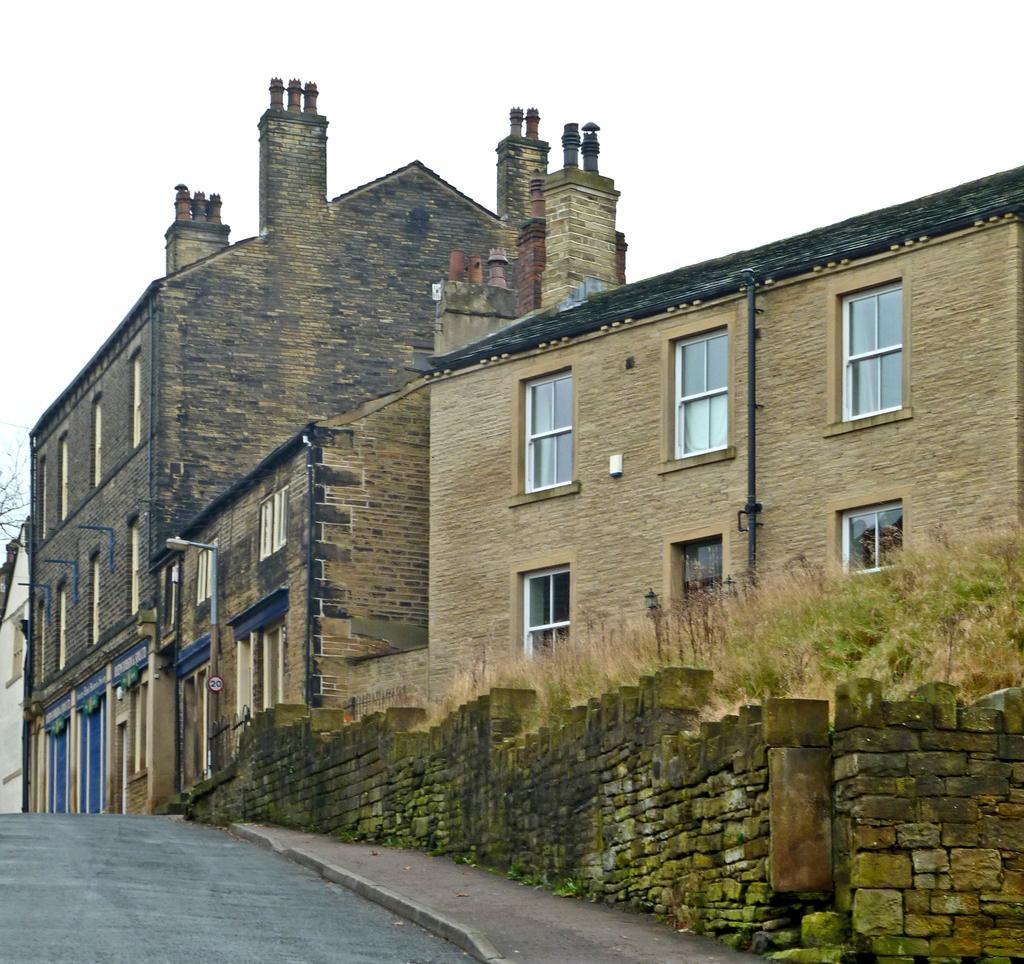In one or two sentences, can you explain what this image depicts? In this image there is road, beside the road there is a house, poles and a small wall and there is grass near the house. 